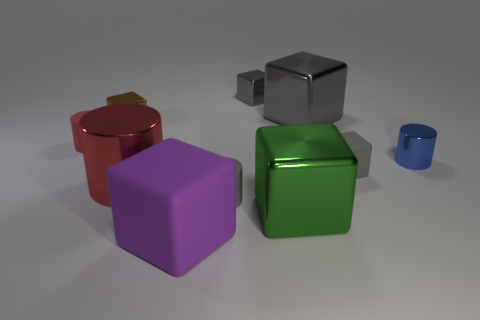Is the material of the tiny gray object that is behind the tiny metallic cylinder the same as the tiny brown cube?
Offer a very short reply. Yes. Is there anything else that is the same size as the red rubber object?
Ensure brevity in your answer.  Yes. Is the number of big red metal objects right of the green metal cube less than the number of large rubber blocks that are on the right side of the small metallic cylinder?
Your response must be concise. No. Is there any other thing that has the same shape as the large matte thing?
Provide a short and direct response. Yes. There is a tiny cylinder that is the same color as the large cylinder; what material is it?
Provide a short and direct response. Rubber. There is a cylinder right of the matte block that is on the right side of the large green thing; how many big red things are right of it?
Your response must be concise. 0. There is a large gray object; how many objects are left of it?
Make the answer very short. 7. What number of blue cylinders have the same material as the tiny red cylinder?
Your answer should be compact. 0. What is the color of the large cylinder that is the same material as the tiny blue thing?
Make the answer very short. Red. What is the material of the tiny cylinder that is on the right side of the small gray cube that is on the left side of the tiny gray rubber thing that is on the right side of the large green shiny block?
Offer a very short reply. Metal. 